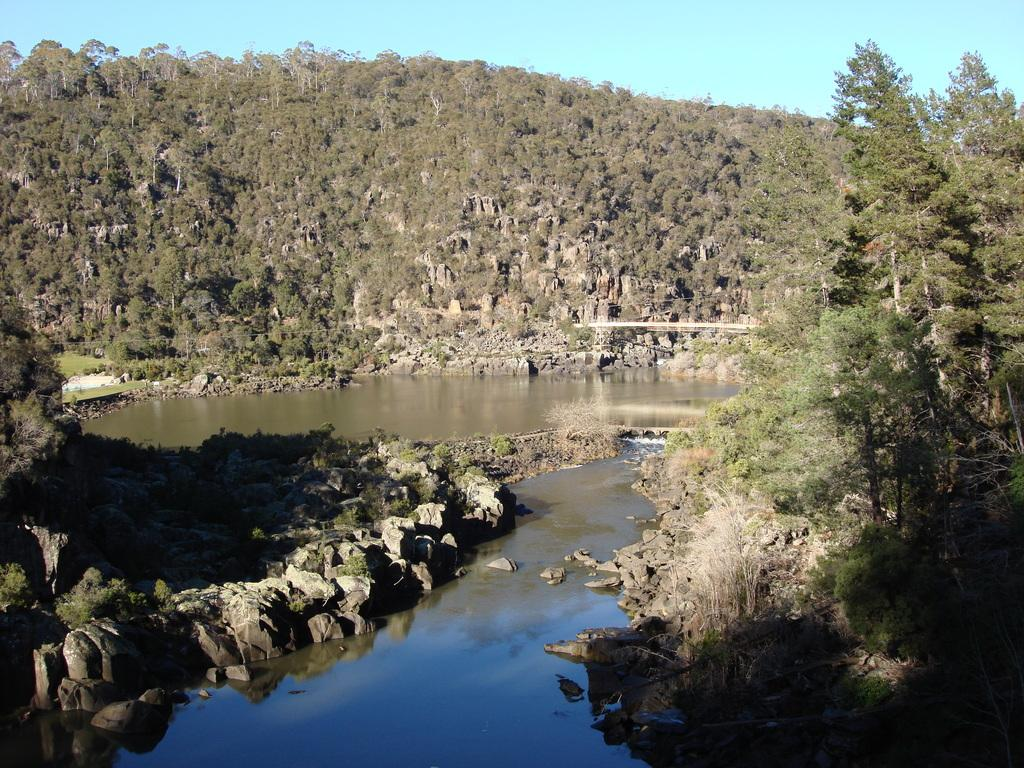What structure can be seen in the image? There is a bridge in the image. What can be seen in the background of the image? There are trees and hills in the background of the image. What is visible at the bottom of the image? There is water visible at the bottom of the image. What type of natural feature can be seen in the image? There are rocks visible in the image. How many kittens are playing on the bridge in the image? There are no kittens present in the image; it features a bridge, trees, hills, water, and rocks. 